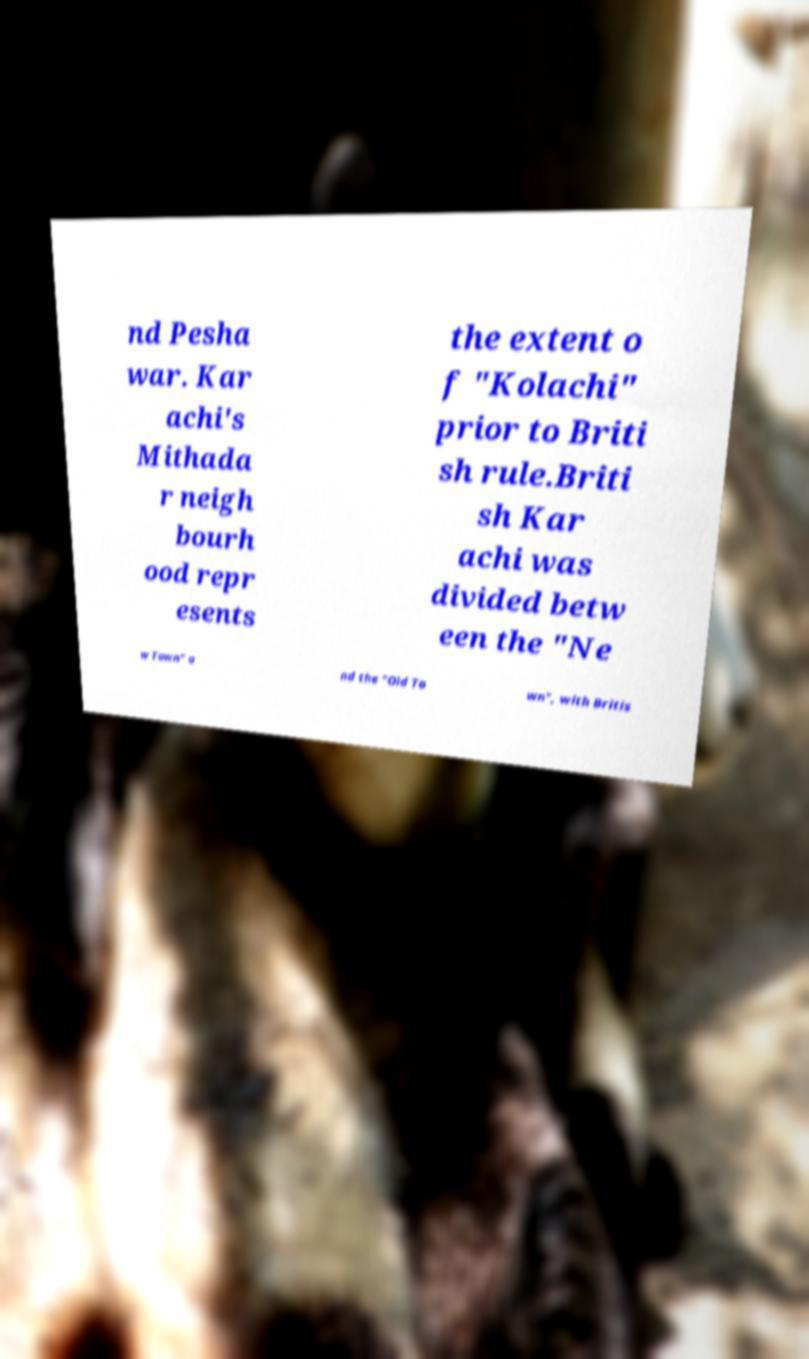What messages or text are displayed in this image? I need them in a readable, typed format. nd Pesha war. Kar achi's Mithada r neigh bourh ood repr esents the extent o f "Kolachi" prior to Briti sh rule.Briti sh Kar achi was divided betw een the "Ne w Town" a nd the "Old To wn", with Britis 